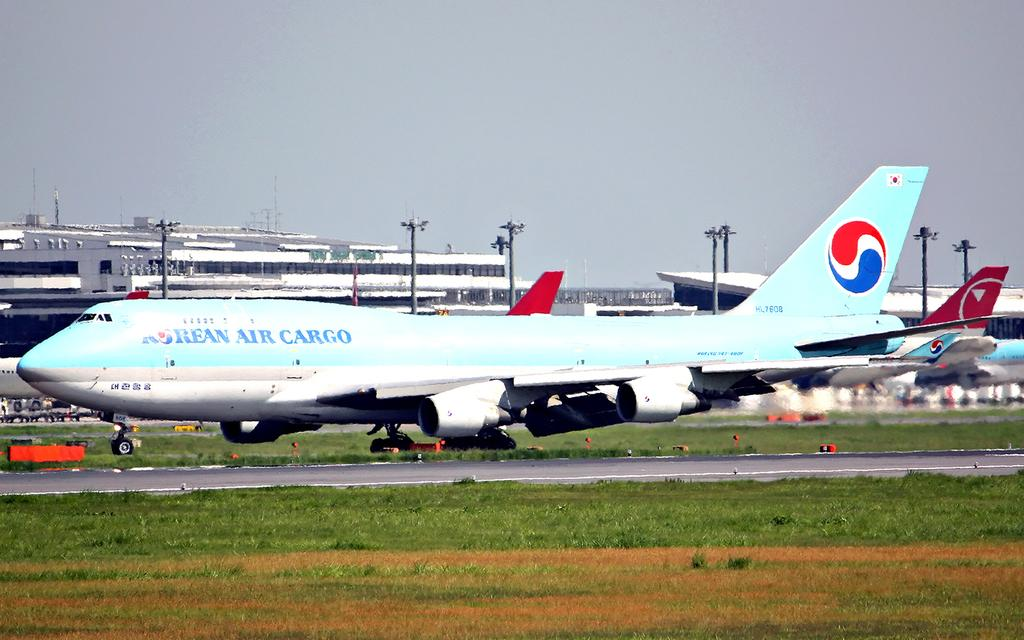<image>
Give a short and clear explanation of the subsequent image. An airplane from the company rean air cargo is at an airport. 